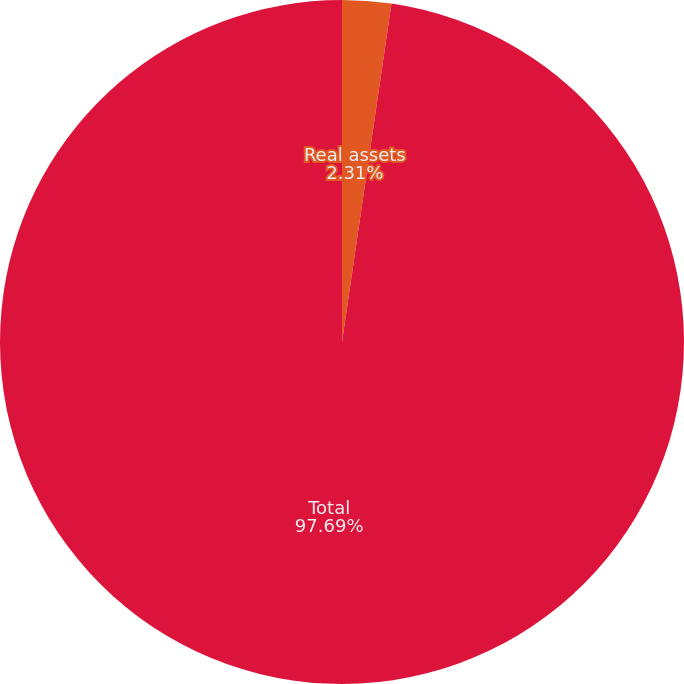<chart> <loc_0><loc_0><loc_500><loc_500><pie_chart><fcel>Real assets<fcel>Total<nl><fcel>2.31%<fcel>97.69%<nl></chart> 